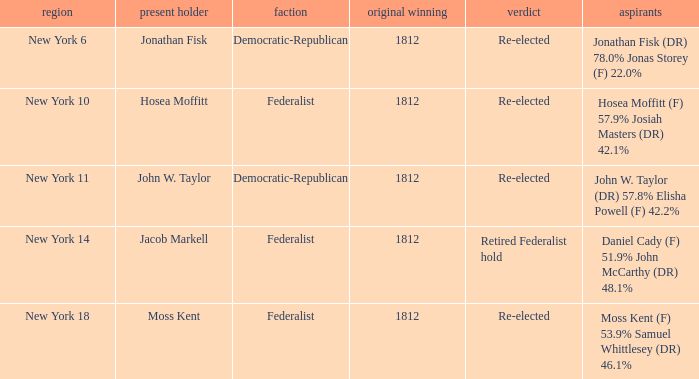State the premier elected member for jacob markell. 1812.0. 